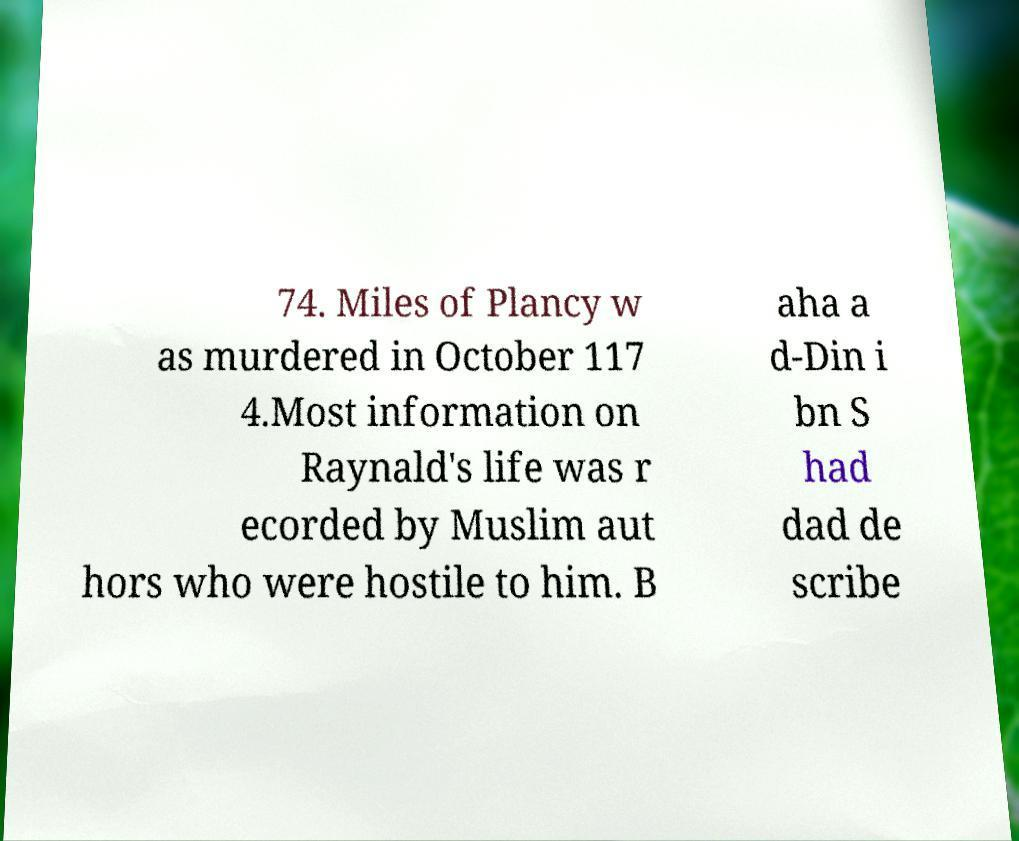I need the written content from this picture converted into text. Can you do that? 74. Miles of Plancy w as murdered in October 117 4.Most information on Raynald's life was r ecorded by Muslim aut hors who were hostile to him. B aha a d-Din i bn S had dad de scribe 